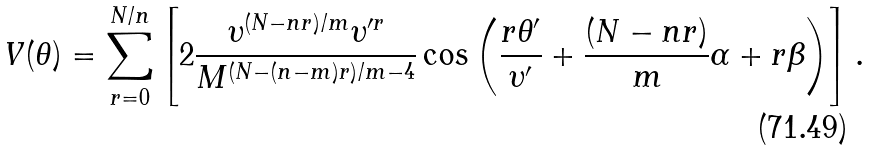Convert formula to latex. <formula><loc_0><loc_0><loc_500><loc_500>V ( \theta ) = \sum _ { r = 0 } ^ { N / n } \left [ 2 \frac { \upsilon ^ { ( N - n r ) / m } \upsilon ^ { \prime r } } { M ^ { ( N - ( n - m ) r ) / m - 4 } } \cos \left ( \frac { r \theta ^ { \prime } } { \upsilon ^ { \prime } } + \frac { ( N - n r ) } { m } \alpha + r \beta \right ) \right ] .</formula> 